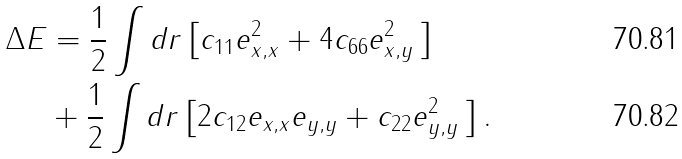Convert formula to latex. <formula><loc_0><loc_0><loc_500><loc_500>\Delta E & = \frac { 1 } { 2 } \int d r \left [ c _ { 1 1 } e _ { x , x } ^ { 2 } + 4 c _ { 6 6 } e _ { x , y } ^ { 2 } \, \right ] \\ & + \frac { 1 } { 2 } \int d r \left [ 2 c _ { 1 2 } e _ { x , x } e _ { y , y } + c _ { 2 2 } e _ { y , y } ^ { 2 } \, \right ] .</formula> 